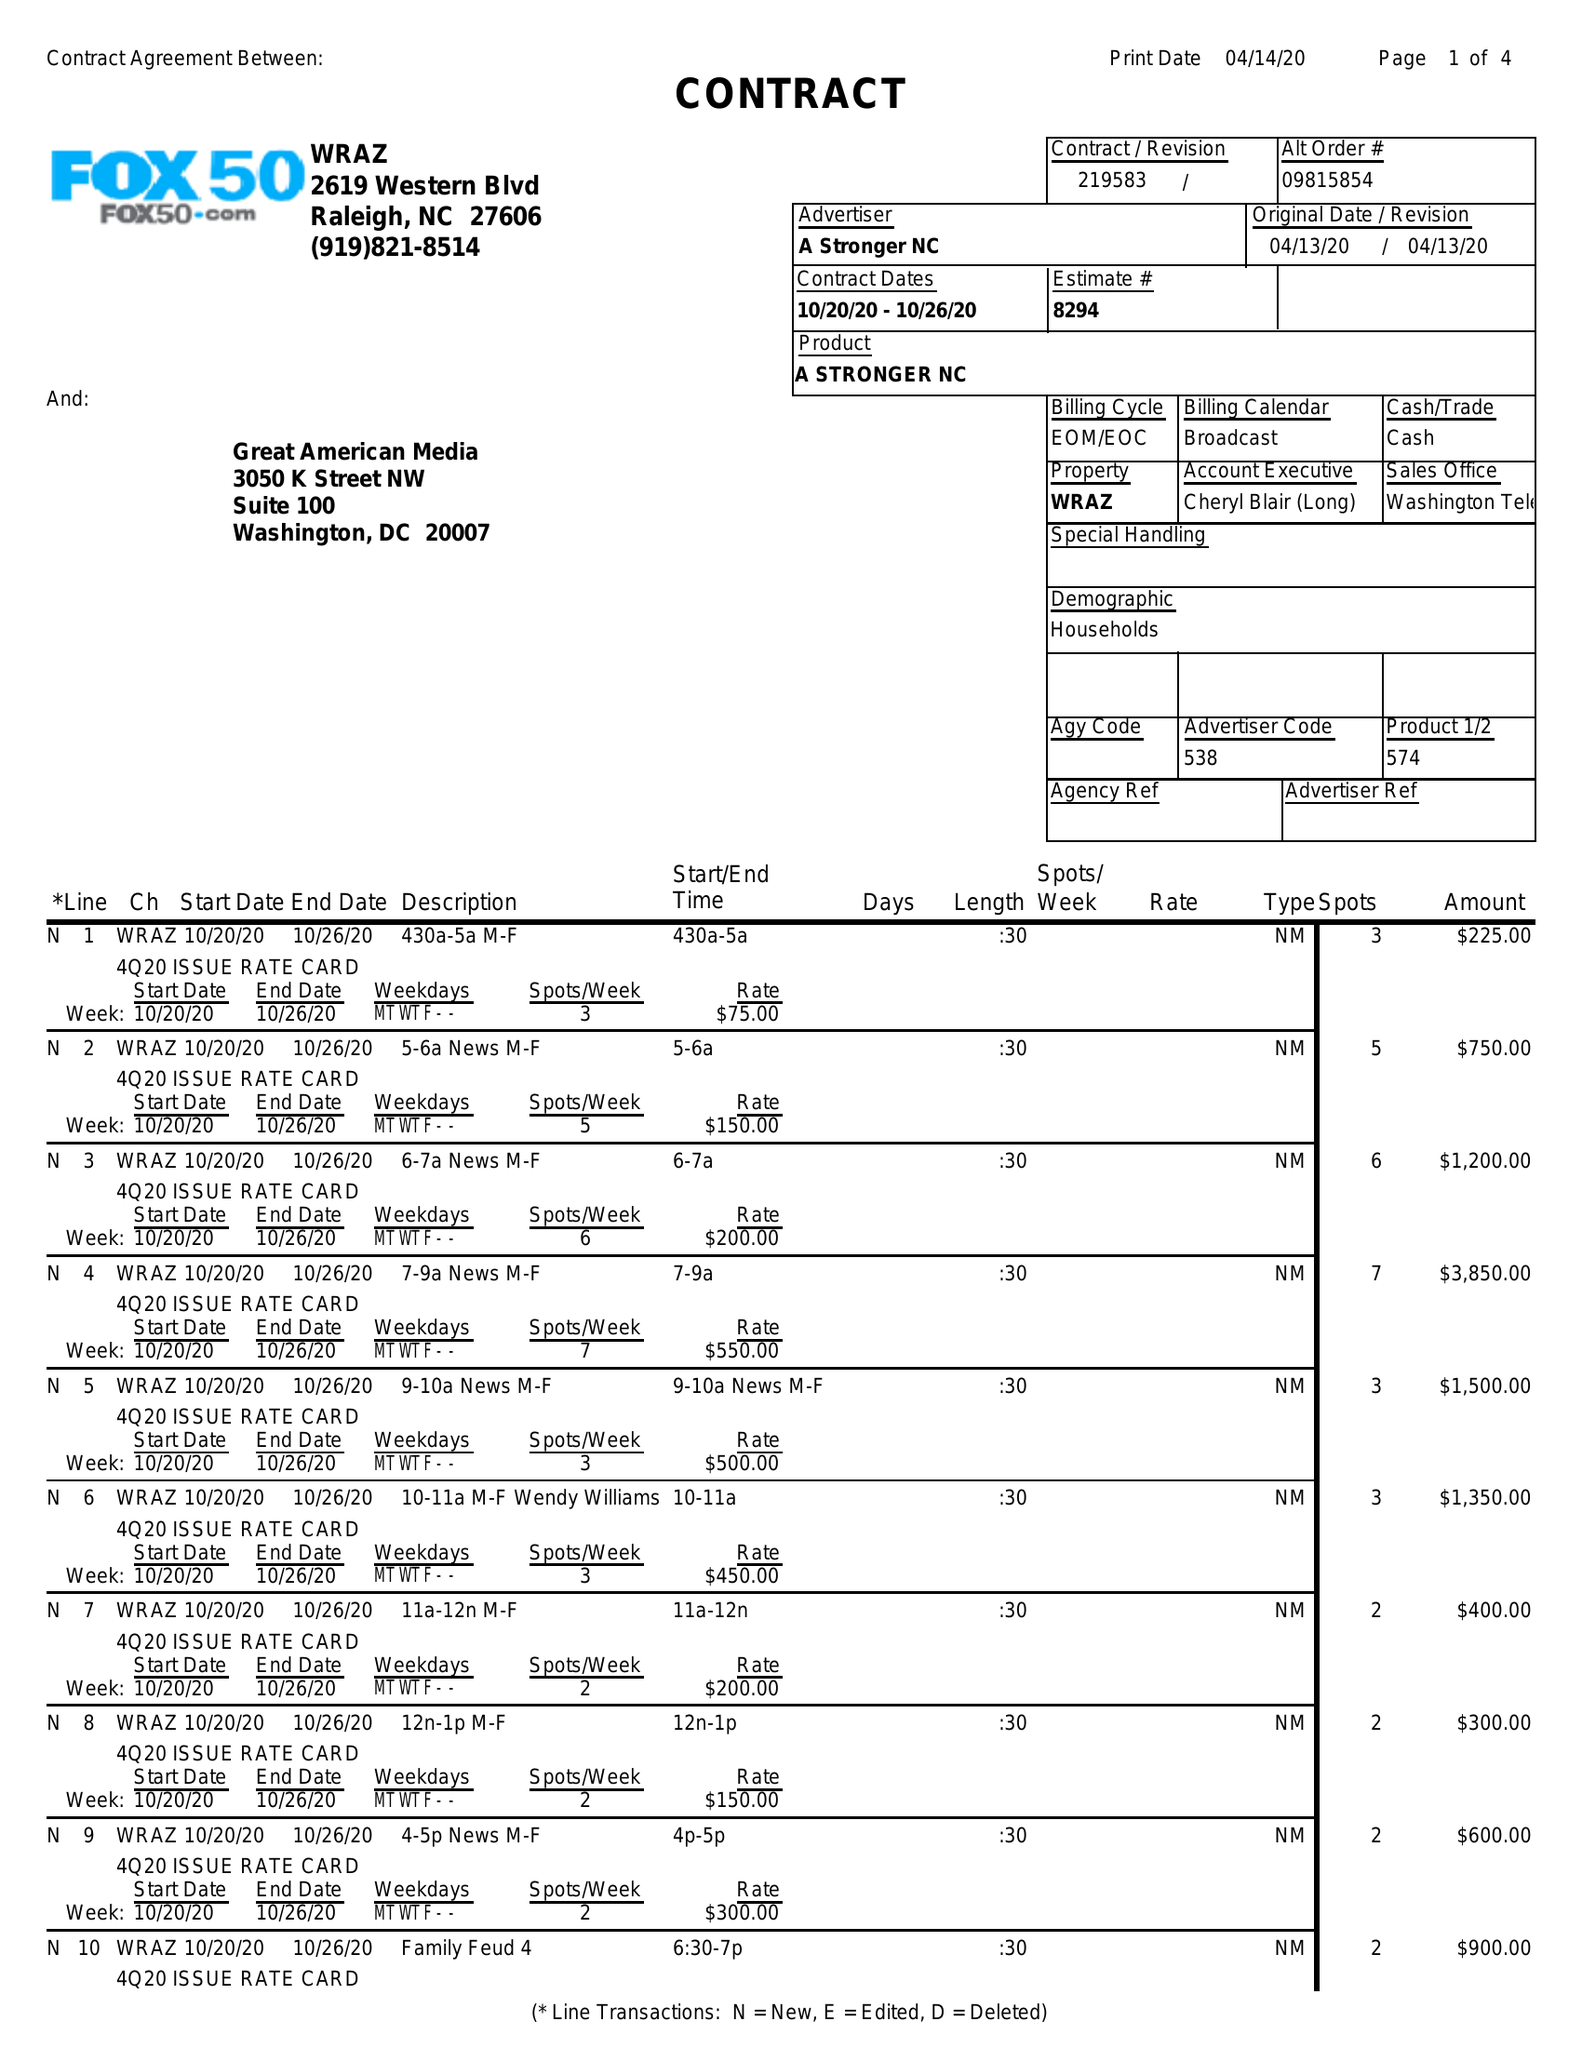What is the value for the gross_amount?
Answer the question using a single word or phrase. 36575.00 